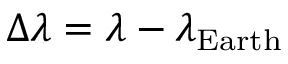<formula> <loc_0><loc_0><loc_500><loc_500>\Delta \lambda = \lambda - \lambda _ { E a r t h }</formula> 